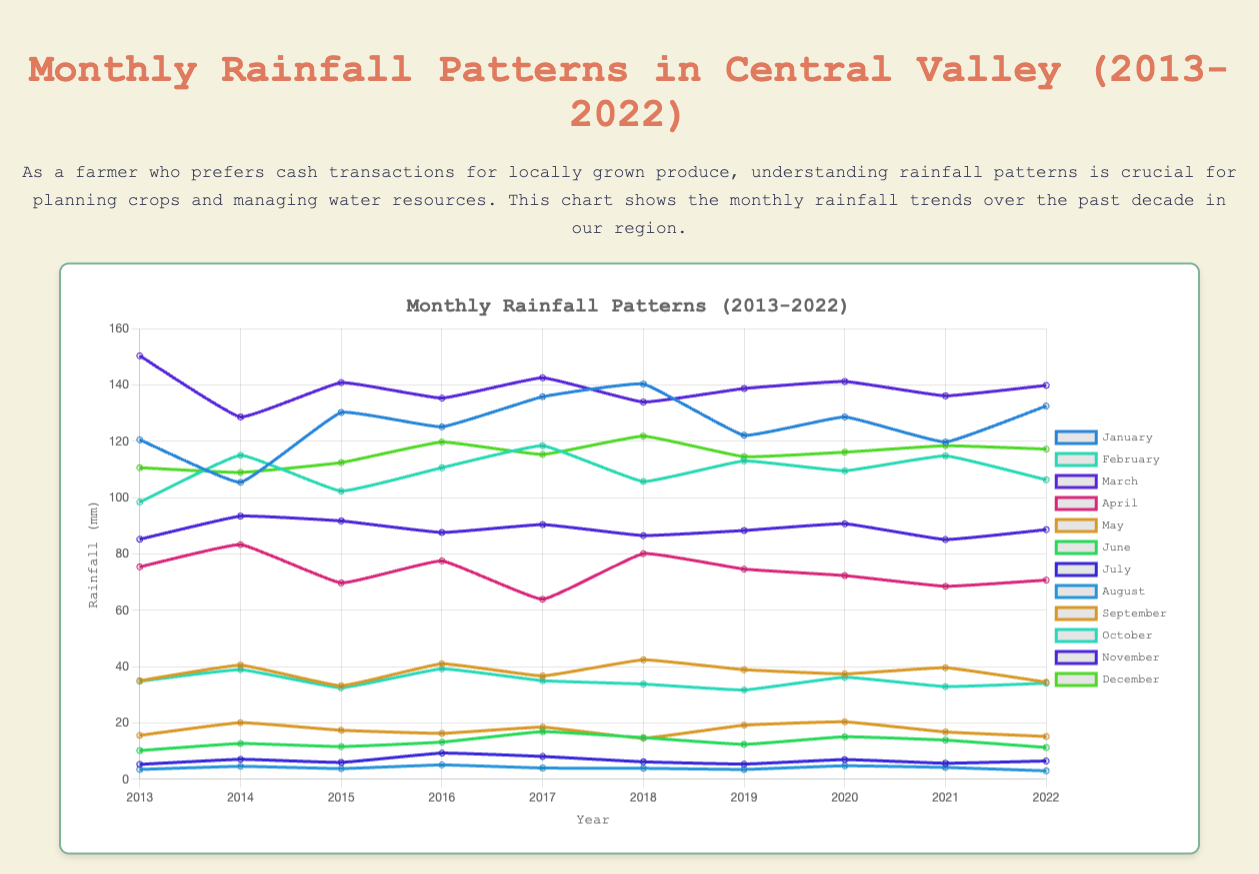Which month had the highest average rainfall over the decade? To find the month with the highest average rainfall, calculate the average rainfall for each month across all years, then compare the averages. For example, January's average is (120.5 + 105.4 + 130.2 + 125.1 + 135.8 + 140.3 + 122.1 + 128.6 + 119.7 + 132.5) / 10. Repeat this for all other months and find the highest average.
Answer: March In which year did January have the maximum rainfall? Look at the rainfall data for January from 2013 to 2022 and identify the year with the highest value. For instance, look at 120.5 (2013), 105.4 (2014), etc., and compare them. The highest value is found in 2018 (140.3 mm).
Answer: 2018 What was the total rainfall in April across all years? Sum the rainfall values for April from 2013 to 2022. Add 75.4 (2013) + 83.3 (2014) + 69.7 (2015) + 77.5 (2016) + 63.9 (2017) + 80.1 (2018) + 74.6 (2019) + 72.3 (2020) + 68.5 (2021) + 70.7 (2022).
Answer: 736 Which year saw the lowest total annual rainfall? For each year, sum the monthly rainfall data and compare the sums to find the lowest total. For instance, sum the rainfall values for all months in 2013, then repeat for other years. Identify the year with the smallest sum.
Answer: 2017 Which year had higher rainfall in February, 2016 or 2020? Look at the rainfall values for February in 2016 and 2020, which are 110.6 mm and 109.5 mm respectively. Compare the two values.
Answer: 2016 Did January in 2018 receive more or less rainfall than January in 2022? Compare the rainfall values for January in 2018 (140.3 mm) and 2022 (132.5 mm). Since 140.3 > 132.5, January in 2018 received more rainfall.
Answer: More What was the average rainfall for November across all years? Calculate the average by summing the rainfall values for November over the decade and dividing by the number of years. (85.2 + 93.4 + 91.7 + 87.6 + 90.4 + 86.5 + 88.3 + 90.7 + 85.1 + 88.6)/10.
Answer: 88.75 Which month has the most visually scattered data points when looking at the chart? Visually observe the chart for the month with highly scattered data points that show significant variances from year to year. Based on the visual attributes, you notice that February data points greatly vary year-on-year.
Answer: February How does the rainfall trend in September compare from 2013 to 2022? Examine the rainfall data for September across the years, looking for an increasing or decreasing trend. Observe a general increase with occasional fluctuations: 15.6 (2013), 20.1 (2014), 17.4 (2015), 16.3 (2016), 18.5 (2017), 14.6 (2018), 19.2 (2019), 20.4 (2020), 16.8 (2021), 15.2 (2022).
Answer: Increasing trend 